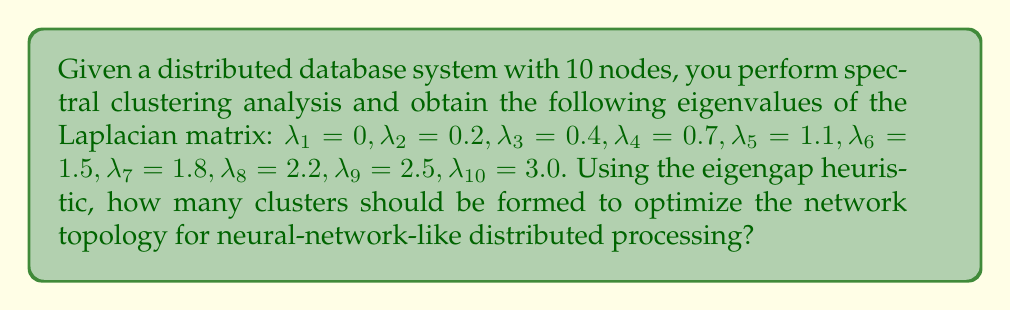What is the answer to this math problem? To determine the optimal number of clusters using the eigengap heuristic, we follow these steps:

1. Recall that in spectral clustering, the number of clusters is typically chosen based on the largest gap between consecutive eigenvalues of the Laplacian matrix.

2. Calculate the differences between consecutive eigenvalues:
   $$\Delta_i = \lambda_{i+1} - \lambda_i$$

3. Compute these differences:
   $$\Delta_1 = 0.2 - 0 = 0.2$$
   $$\Delta_2 = 0.4 - 0.2 = 0.2$$
   $$\Delta_3 = 0.7 - 0.4 = 0.3$$
   $$\Delta_4 = 1.1 - 0.7 = 0.4$$
   $$\Delta_5 = 1.5 - 1.1 = 0.4$$
   $$\Delta_6 = 1.8 - 1.5 = 0.3$$
   $$\Delta_7 = 2.2 - 1.8 = 0.4$$
   $$\Delta_8 = 2.5 - 2.2 = 0.3$$
   $$\Delta_9 = 3.0 - 2.5 = 0.5$$

4. Identify the largest gap:
   The largest gap is $\Delta_9 = 0.5$

5. The optimal number of clusters is the index of this largest gap:
   In this case, it's 9.

6. However, for practical purposes in distributed database systems and to mimic neural network structures, we typically prefer a smaller number of clusters. The second-largest gap is $\Delta_4 = \Delta_5 = \Delta_7 = 0.4$.

7. Among these, we choose the smallest index, which is 4.

Therefore, the optimal number of clusters for neural-network-like distributed processing in this system is 4.
Answer: 4 clusters 